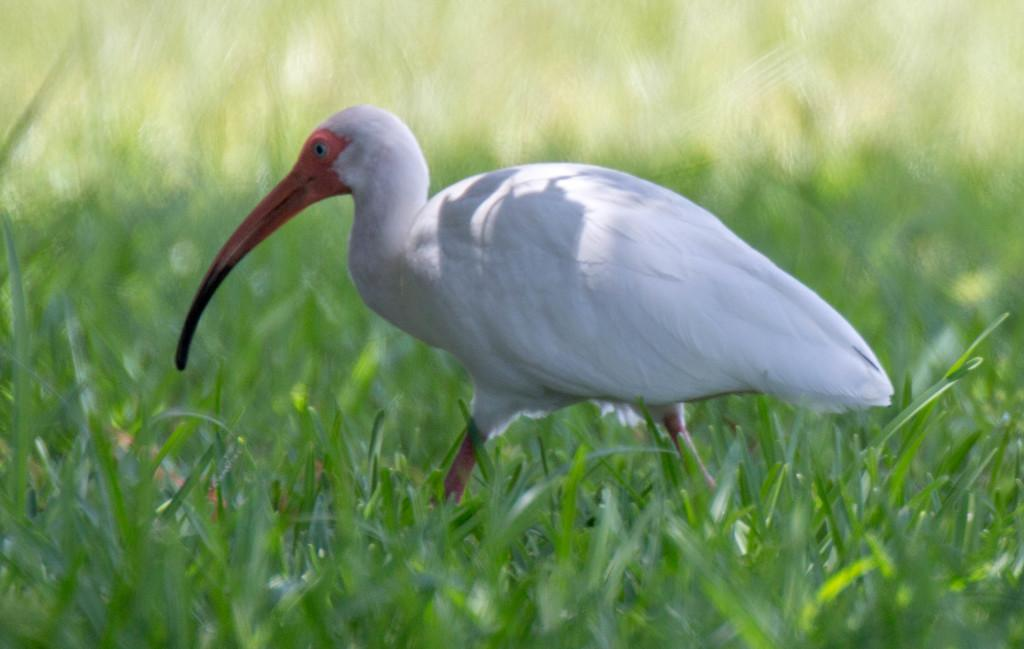What type of animal can be seen in the image? There is a bird in the image. What type of vegetation is present in the image? There is grass in the image. What advice does the bird give to the volleyball player in the image? There is no volleyball player or advice present in the image; it features a bird and grass. What type of jelly is being used to create the bird's nest in the image? There is no jelly or nest present in the image; it features a bird and grass. 